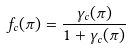Convert formula to latex. <formula><loc_0><loc_0><loc_500><loc_500>f _ { c } ( \pi ) = \frac { \gamma _ { c } ( \pi ) } { 1 + \gamma _ { c } ( \pi ) }</formula> 